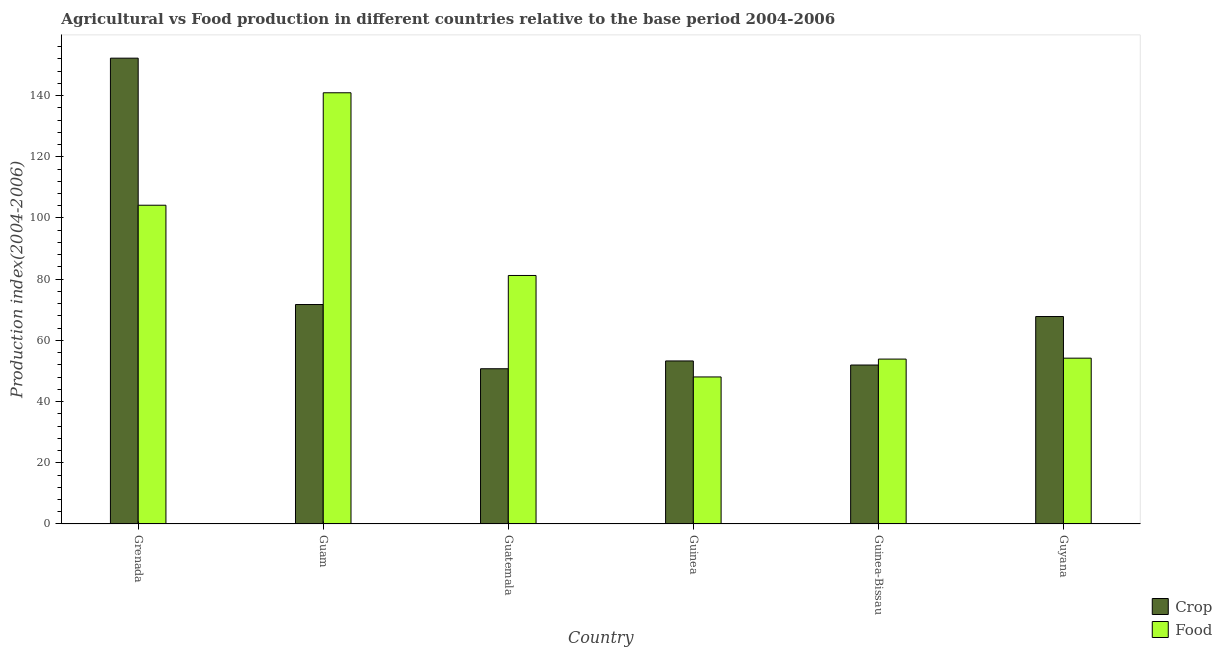How many bars are there on the 4th tick from the left?
Provide a succinct answer. 2. How many bars are there on the 1st tick from the right?
Offer a terse response. 2. What is the label of the 1st group of bars from the left?
Keep it short and to the point. Grenada. What is the food production index in Guam?
Keep it short and to the point. 140.92. Across all countries, what is the maximum crop production index?
Ensure brevity in your answer.  152.23. Across all countries, what is the minimum food production index?
Provide a succinct answer. 48.05. In which country was the crop production index maximum?
Your answer should be very brief. Grenada. In which country was the food production index minimum?
Provide a succinct answer. Guinea. What is the total crop production index in the graph?
Provide a short and direct response. 447.71. What is the difference between the crop production index in Guatemala and that in Guinea?
Your answer should be compact. -2.55. What is the difference between the crop production index in Guyana and the food production index in Grenada?
Your answer should be compact. -36.37. What is the average food production index per country?
Your answer should be very brief. 80.4. What is the difference between the crop production index and food production index in Grenada?
Provide a succinct answer. 48.06. What is the ratio of the food production index in Guatemala to that in Guinea?
Offer a terse response. 1.69. Is the food production index in Grenada less than that in Guinea-Bissau?
Make the answer very short. No. Is the difference between the crop production index in Guinea and Guinea-Bissau greater than the difference between the food production index in Guinea and Guinea-Bissau?
Provide a short and direct response. Yes. What is the difference between the highest and the second highest crop production index?
Provide a succinct answer. 80.51. What is the difference between the highest and the lowest food production index?
Your response must be concise. 92.87. In how many countries, is the crop production index greater than the average crop production index taken over all countries?
Provide a short and direct response. 1. Is the sum of the food production index in Grenada and Guam greater than the maximum crop production index across all countries?
Make the answer very short. Yes. What does the 1st bar from the left in Grenada represents?
Keep it short and to the point. Crop. What does the 2nd bar from the right in Guinea-Bissau represents?
Offer a terse response. Crop. Are the values on the major ticks of Y-axis written in scientific E-notation?
Keep it short and to the point. No. Does the graph contain grids?
Offer a terse response. No. Where does the legend appear in the graph?
Provide a short and direct response. Bottom right. How are the legend labels stacked?
Give a very brief answer. Vertical. What is the title of the graph?
Your answer should be compact. Agricultural vs Food production in different countries relative to the base period 2004-2006. What is the label or title of the X-axis?
Ensure brevity in your answer.  Country. What is the label or title of the Y-axis?
Keep it short and to the point. Production index(2004-2006). What is the Production index(2004-2006) of Crop in Grenada?
Provide a succinct answer. 152.23. What is the Production index(2004-2006) in Food in Grenada?
Offer a very short reply. 104.17. What is the Production index(2004-2006) of Crop in Guam?
Ensure brevity in your answer.  71.72. What is the Production index(2004-2006) of Food in Guam?
Your answer should be very brief. 140.92. What is the Production index(2004-2006) of Crop in Guatemala?
Your response must be concise. 50.73. What is the Production index(2004-2006) in Food in Guatemala?
Offer a terse response. 81.21. What is the Production index(2004-2006) in Crop in Guinea?
Make the answer very short. 53.28. What is the Production index(2004-2006) of Food in Guinea?
Keep it short and to the point. 48.05. What is the Production index(2004-2006) of Crop in Guinea-Bissau?
Your answer should be very brief. 51.95. What is the Production index(2004-2006) in Food in Guinea-Bissau?
Give a very brief answer. 53.89. What is the Production index(2004-2006) in Crop in Guyana?
Give a very brief answer. 67.8. What is the Production index(2004-2006) in Food in Guyana?
Offer a terse response. 54.19. Across all countries, what is the maximum Production index(2004-2006) in Crop?
Ensure brevity in your answer.  152.23. Across all countries, what is the maximum Production index(2004-2006) of Food?
Offer a very short reply. 140.92. Across all countries, what is the minimum Production index(2004-2006) in Crop?
Offer a terse response. 50.73. Across all countries, what is the minimum Production index(2004-2006) of Food?
Give a very brief answer. 48.05. What is the total Production index(2004-2006) in Crop in the graph?
Your answer should be very brief. 447.71. What is the total Production index(2004-2006) in Food in the graph?
Offer a terse response. 482.43. What is the difference between the Production index(2004-2006) in Crop in Grenada and that in Guam?
Keep it short and to the point. 80.51. What is the difference between the Production index(2004-2006) of Food in Grenada and that in Guam?
Offer a terse response. -36.75. What is the difference between the Production index(2004-2006) in Crop in Grenada and that in Guatemala?
Provide a short and direct response. 101.5. What is the difference between the Production index(2004-2006) of Food in Grenada and that in Guatemala?
Ensure brevity in your answer.  22.96. What is the difference between the Production index(2004-2006) in Crop in Grenada and that in Guinea?
Make the answer very short. 98.95. What is the difference between the Production index(2004-2006) of Food in Grenada and that in Guinea?
Provide a succinct answer. 56.12. What is the difference between the Production index(2004-2006) in Crop in Grenada and that in Guinea-Bissau?
Ensure brevity in your answer.  100.28. What is the difference between the Production index(2004-2006) in Food in Grenada and that in Guinea-Bissau?
Your answer should be compact. 50.28. What is the difference between the Production index(2004-2006) of Crop in Grenada and that in Guyana?
Offer a terse response. 84.43. What is the difference between the Production index(2004-2006) in Food in Grenada and that in Guyana?
Your answer should be very brief. 49.98. What is the difference between the Production index(2004-2006) of Crop in Guam and that in Guatemala?
Ensure brevity in your answer.  20.99. What is the difference between the Production index(2004-2006) in Food in Guam and that in Guatemala?
Give a very brief answer. 59.71. What is the difference between the Production index(2004-2006) in Crop in Guam and that in Guinea?
Your response must be concise. 18.44. What is the difference between the Production index(2004-2006) in Food in Guam and that in Guinea?
Give a very brief answer. 92.87. What is the difference between the Production index(2004-2006) in Crop in Guam and that in Guinea-Bissau?
Your answer should be compact. 19.77. What is the difference between the Production index(2004-2006) of Food in Guam and that in Guinea-Bissau?
Your answer should be compact. 87.03. What is the difference between the Production index(2004-2006) in Crop in Guam and that in Guyana?
Keep it short and to the point. 3.92. What is the difference between the Production index(2004-2006) in Food in Guam and that in Guyana?
Your answer should be very brief. 86.73. What is the difference between the Production index(2004-2006) of Crop in Guatemala and that in Guinea?
Offer a very short reply. -2.55. What is the difference between the Production index(2004-2006) in Food in Guatemala and that in Guinea?
Make the answer very short. 33.16. What is the difference between the Production index(2004-2006) in Crop in Guatemala and that in Guinea-Bissau?
Provide a succinct answer. -1.22. What is the difference between the Production index(2004-2006) in Food in Guatemala and that in Guinea-Bissau?
Make the answer very short. 27.32. What is the difference between the Production index(2004-2006) in Crop in Guatemala and that in Guyana?
Keep it short and to the point. -17.07. What is the difference between the Production index(2004-2006) of Food in Guatemala and that in Guyana?
Offer a terse response. 27.02. What is the difference between the Production index(2004-2006) in Crop in Guinea and that in Guinea-Bissau?
Make the answer very short. 1.33. What is the difference between the Production index(2004-2006) in Food in Guinea and that in Guinea-Bissau?
Offer a very short reply. -5.84. What is the difference between the Production index(2004-2006) in Crop in Guinea and that in Guyana?
Your answer should be very brief. -14.52. What is the difference between the Production index(2004-2006) of Food in Guinea and that in Guyana?
Offer a very short reply. -6.14. What is the difference between the Production index(2004-2006) of Crop in Guinea-Bissau and that in Guyana?
Ensure brevity in your answer.  -15.85. What is the difference between the Production index(2004-2006) of Food in Guinea-Bissau and that in Guyana?
Offer a very short reply. -0.3. What is the difference between the Production index(2004-2006) in Crop in Grenada and the Production index(2004-2006) in Food in Guam?
Keep it short and to the point. 11.31. What is the difference between the Production index(2004-2006) of Crop in Grenada and the Production index(2004-2006) of Food in Guatemala?
Your answer should be very brief. 71.02. What is the difference between the Production index(2004-2006) in Crop in Grenada and the Production index(2004-2006) in Food in Guinea?
Offer a very short reply. 104.18. What is the difference between the Production index(2004-2006) in Crop in Grenada and the Production index(2004-2006) in Food in Guinea-Bissau?
Your response must be concise. 98.34. What is the difference between the Production index(2004-2006) in Crop in Grenada and the Production index(2004-2006) in Food in Guyana?
Ensure brevity in your answer.  98.04. What is the difference between the Production index(2004-2006) in Crop in Guam and the Production index(2004-2006) in Food in Guatemala?
Offer a terse response. -9.49. What is the difference between the Production index(2004-2006) in Crop in Guam and the Production index(2004-2006) in Food in Guinea?
Make the answer very short. 23.67. What is the difference between the Production index(2004-2006) of Crop in Guam and the Production index(2004-2006) of Food in Guinea-Bissau?
Provide a succinct answer. 17.83. What is the difference between the Production index(2004-2006) of Crop in Guam and the Production index(2004-2006) of Food in Guyana?
Your response must be concise. 17.53. What is the difference between the Production index(2004-2006) in Crop in Guatemala and the Production index(2004-2006) in Food in Guinea?
Provide a short and direct response. 2.68. What is the difference between the Production index(2004-2006) of Crop in Guatemala and the Production index(2004-2006) of Food in Guinea-Bissau?
Give a very brief answer. -3.16. What is the difference between the Production index(2004-2006) of Crop in Guatemala and the Production index(2004-2006) of Food in Guyana?
Your answer should be compact. -3.46. What is the difference between the Production index(2004-2006) in Crop in Guinea and the Production index(2004-2006) in Food in Guinea-Bissau?
Offer a terse response. -0.61. What is the difference between the Production index(2004-2006) in Crop in Guinea and the Production index(2004-2006) in Food in Guyana?
Keep it short and to the point. -0.91. What is the difference between the Production index(2004-2006) of Crop in Guinea-Bissau and the Production index(2004-2006) of Food in Guyana?
Ensure brevity in your answer.  -2.24. What is the average Production index(2004-2006) of Crop per country?
Provide a succinct answer. 74.62. What is the average Production index(2004-2006) of Food per country?
Your answer should be compact. 80.41. What is the difference between the Production index(2004-2006) in Crop and Production index(2004-2006) in Food in Grenada?
Give a very brief answer. 48.06. What is the difference between the Production index(2004-2006) of Crop and Production index(2004-2006) of Food in Guam?
Make the answer very short. -69.2. What is the difference between the Production index(2004-2006) of Crop and Production index(2004-2006) of Food in Guatemala?
Offer a very short reply. -30.48. What is the difference between the Production index(2004-2006) of Crop and Production index(2004-2006) of Food in Guinea?
Provide a succinct answer. 5.23. What is the difference between the Production index(2004-2006) of Crop and Production index(2004-2006) of Food in Guinea-Bissau?
Provide a short and direct response. -1.94. What is the difference between the Production index(2004-2006) in Crop and Production index(2004-2006) in Food in Guyana?
Make the answer very short. 13.61. What is the ratio of the Production index(2004-2006) of Crop in Grenada to that in Guam?
Provide a short and direct response. 2.12. What is the ratio of the Production index(2004-2006) in Food in Grenada to that in Guam?
Make the answer very short. 0.74. What is the ratio of the Production index(2004-2006) of Crop in Grenada to that in Guatemala?
Provide a short and direct response. 3. What is the ratio of the Production index(2004-2006) in Food in Grenada to that in Guatemala?
Ensure brevity in your answer.  1.28. What is the ratio of the Production index(2004-2006) of Crop in Grenada to that in Guinea?
Give a very brief answer. 2.86. What is the ratio of the Production index(2004-2006) of Food in Grenada to that in Guinea?
Ensure brevity in your answer.  2.17. What is the ratio of the Production index(2004-2006) in Crop in Grenada to that in Guinea-Bissau?
Make the answer very short. 2.93. What is the ratio of the Production index(2004-2006) in Food in Grenada to that in Guinea-Bissau?
Your answer should be compact. 1.93. What is the ratio of the Production index(2004-2006) of Crop in Grenada to that in Guyana?
Provide a succinct answer. 2.25. What is the ratio of the Production index(2004-2006) in Food in Grenada to that in Guyana?
Offer a terse response. 1.92. What is the ratio of the Production index(2004-2006) in Crop in Guam to that in Guatemala?
Your answer should be compact. 1.41. What is the ratio of the Production index(2004-2006) in Food in Guam to that in Guatemala?
Provide a short and direct response. 1.74. What is the ratio of the Production index(2004-2006) of Crop in Guam to that in Guinea?
Your answer should be very brief. 1.35. What is the ratio of the Production index(2004-2006) in Food in Guam to that in Guinea?
Give a very brief answer. 2.93. What is the ratio of the Production index(2004-2006) in Crop in Guam to that in Guinea-Bissau?
Your answer should be very brief. 1.38. What is the ratio of the Production index(2004-2006) of Food in Guam to that in Guinea-Bissau?
Give a very brief answer. 2.62. What is the ratio of the Production index(2004-2006) of Crop in Guam to that in Guyana?
Ensure brevity in your answer.  1.06. What is the ratio of the Production index(2004-2006) in Food in Guam to that in Guyana?
Offer a very short reply. 2.6. What is the ratio of the Production index(2004-2006) in Crop in Guatemala to that in Guinea?
Your answer should be very brief. 0.95. What is the ratio of the Production index(2004-2006) in Food in Guatemala to that in Guinea?
Offer a very short reply. 1.69. What is the ratio of the Production index(2004-2006) of Crop in Guatemala to that in Guinea-Bissau?
Offer a very short reply. 0.98. What is the ratio of the Production index(2004-2006) of Food in Guatemala to that in Guinea-Bissau?
Ensure brevity in your answer.  1.51. What is the ratio of the Production index(2004-2006) in Crop in Guatemala to that in Guyana?
Give a very brief answer. 0.75. What is the ratio of the Production index(2004-2006) in Food in Guatemala to that in Guyana?
Ensure brevity in your answer.  1.5. What is the ratio of the Production index(2004-2006) of Crop in Guinea to that in Guinea-Bissau?
Make the answer very short. 1.03. What is the ratio of the Production index(2004-2006) of Food in Guinea to that in Guinea-Bissau?
Your answer should be very brief. 0.89. What is the ratio of the Production index(2004-2006) in Crop in Guinea to that in Guyana?
Offer a very short reply. 0.79. What is the ratio of the Production index(2004-2006) in Food in Guinea to that in Guyana?
Offer a terse response. 0.89. What is the ratio of the Production index(2004-2006) of Crop in Guinea-Bissau to that in Guyana?
Provide a succinct answer. 0.77. What is the ratio of the Production index(2004-2006) in Food in Guinea-Bissau to that in Guyana?
Offer a very short reply. 0.99. What is the difference between the highest and the second highest Production index(2004-2006) of Crop?
Your answer should be compact. 80.51. What is the difference between the highest and the second highest Production index(2004-2006) in Food?
Ensure brevity in your answer.  36.75. What is the difference between the highest and the lowest Production index(2004-2006) of Crop?
Keep it short and to the point. 101.5. What is the difference between the highest and the lowest Production index(2004-2006) in Food?
Give a very brief answer. 92.87. 